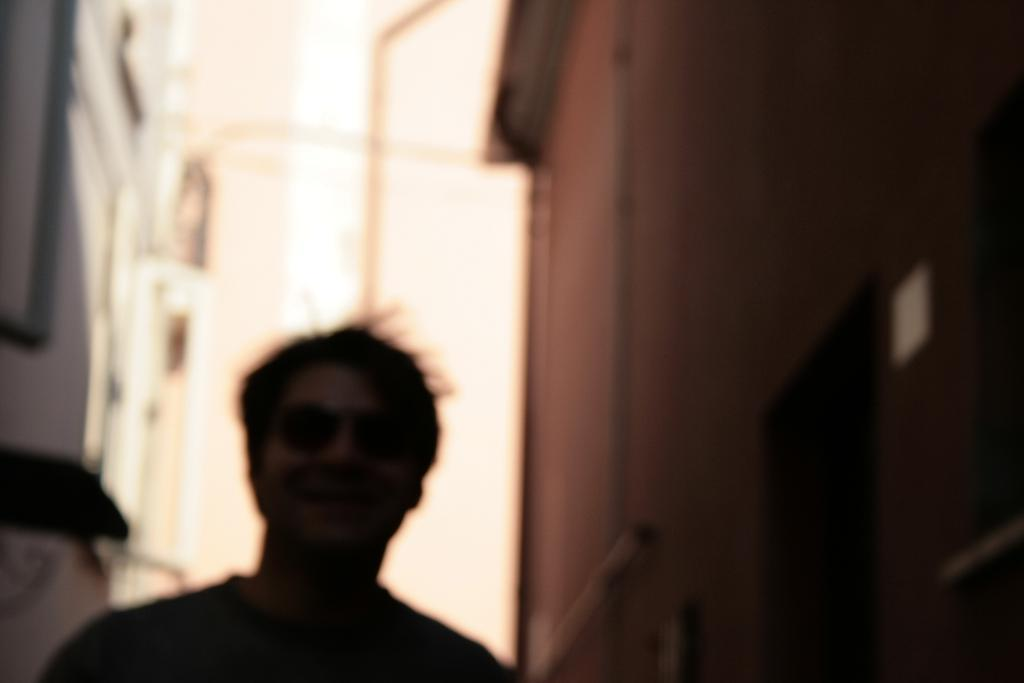Who is present in the image? There is a man in the image. What is the man doing in the image? The man is smiling and giving a pose. How would you describe the background of the image? The background of the image is blurred. What can be seen on the right side of the image? There is a big brown wall on the right side of the image. How many giants are visible in the image? There are no giants present in the image. What type of rock is the man standing on in the image? The image does not show the man standing on any rock; it only shows a man giving a pose in front of a blurred background and a big brown wall. 